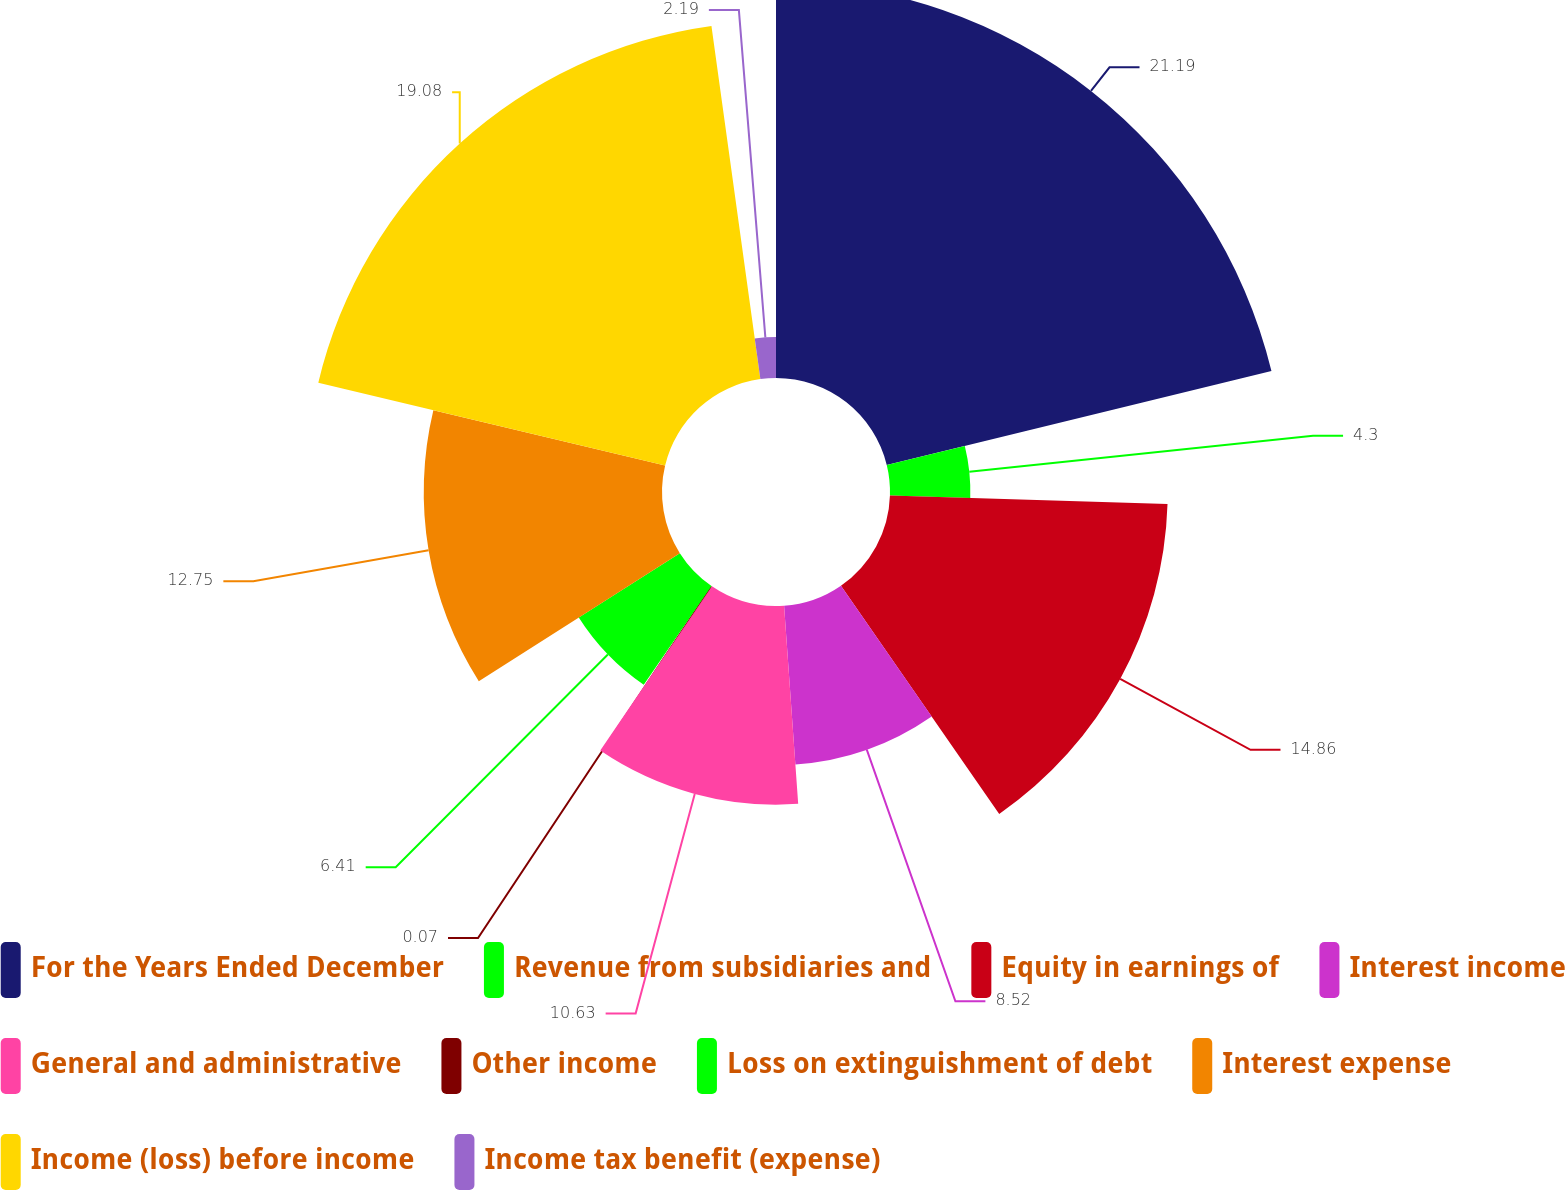Convert chart to OTSL. <chart><loc_0><loc_0><loc_500><loc_500><pie_chart><fcel>For the Years Ended December<fcel>Revenue from subsidiaries and<fcel>Equity in earnings of<fcel>Interest income<fcel>General and administrative<fcel>Other income<fcel>Loss on extinguishment of debt<fcel>Interest expense<fcel>Income (loss) before income<fcel>Income tax benefit (expense)<nl><fcel>21.19%<fcel>4.3%<fcel>14.86%<fcel>8.52%<fcel>10.63%<fcel>0.07%<fcel>6.41%<fcel>12.75%<fcel>19.08%<fcel>2.19%<nl></chart> 